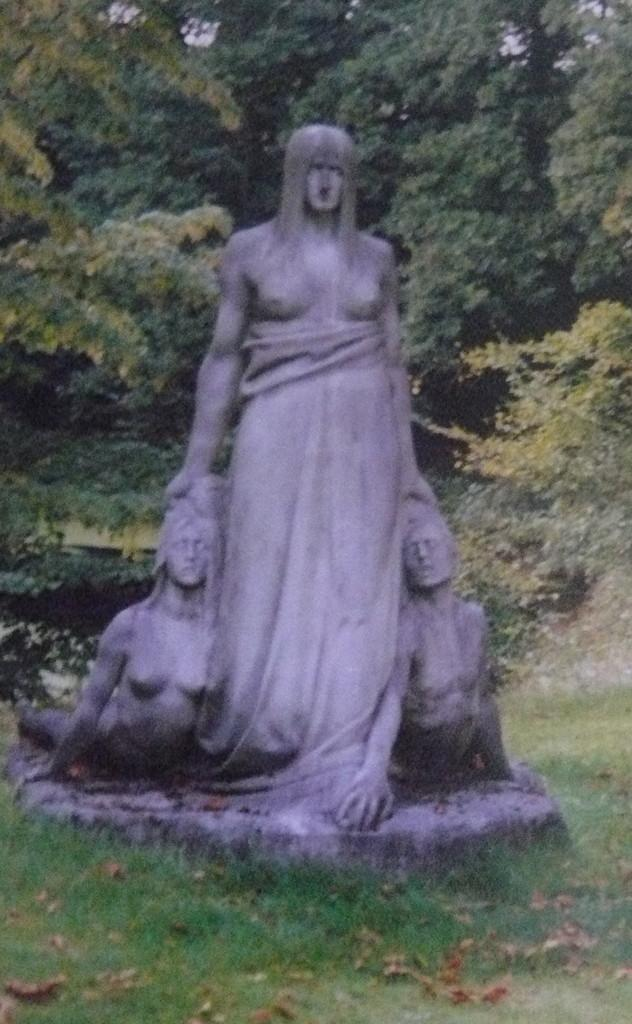What is depicted on the ground in the image? There is a statue of three persons on the ground. What type of vegetation can be seen in the image? There are leaves, grass, and green trees visible in the image. How many horses are present in the image? There are no horses present in the image. What type of boats can be seen in the image? There are no boats present in the image. 